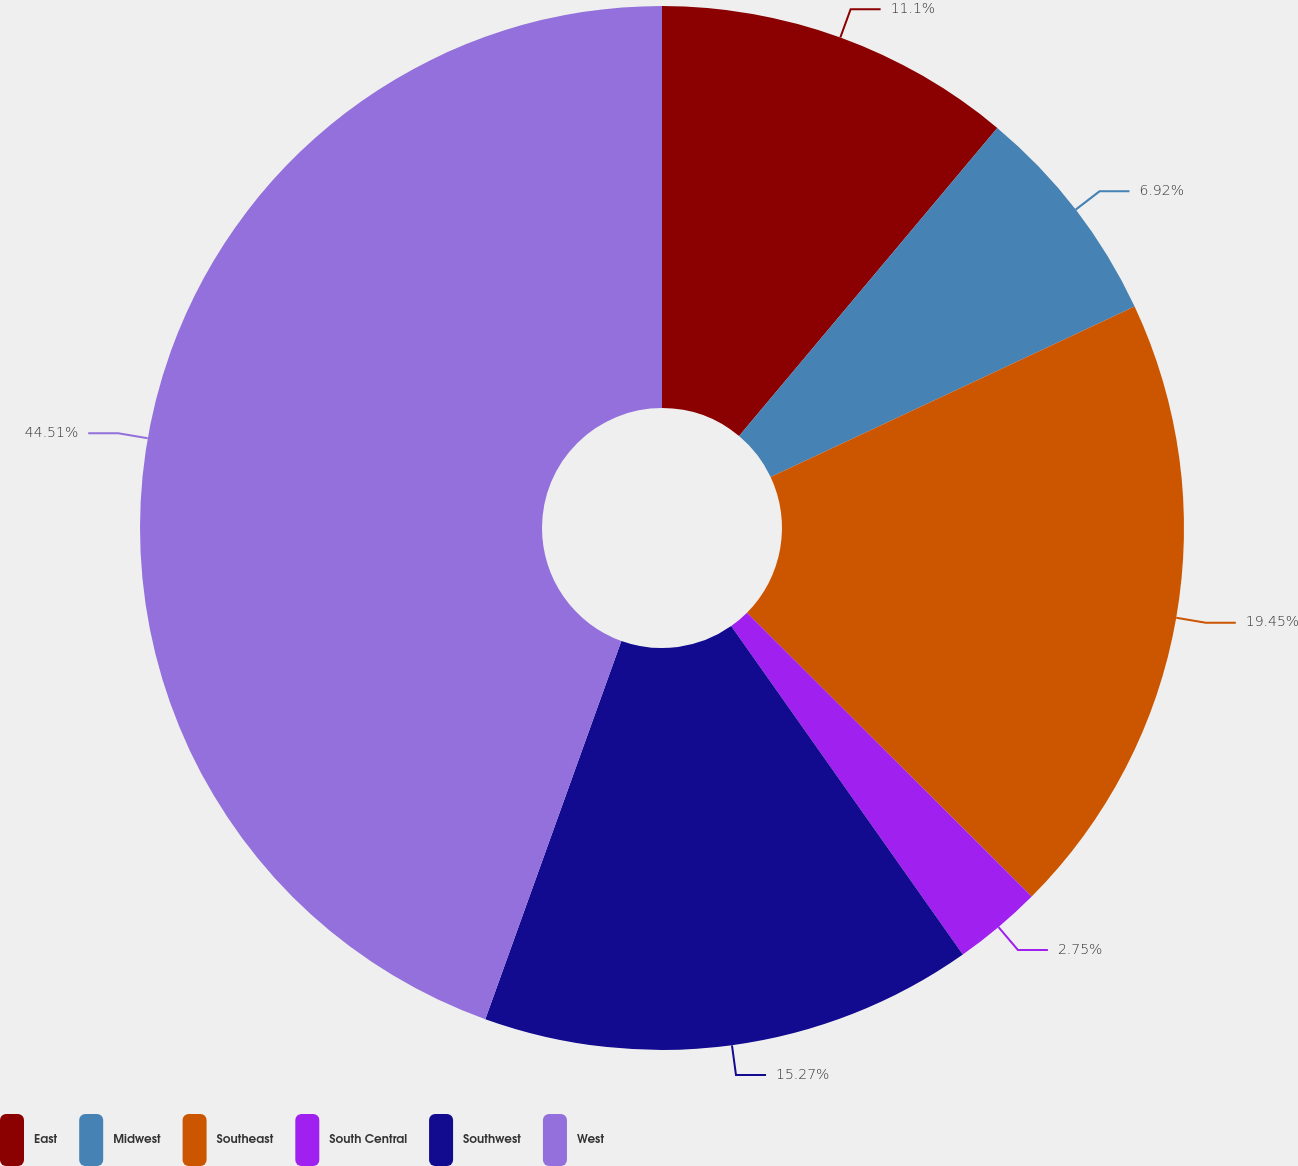Convert chart to OTSL. <chart><loc_0><loc_0><loc_500><loc_500><pie_chart><fcel>East<fcel>Midwest<fcel>Southeast<fcel>South Central<fcel>Southwest<fcel>West<nl><fcel>11.1%<fcel>6.92%<fcel>19.45%<fcel>2.75%<fcel>15.27%<fcel>44.5%<nl></chart> 